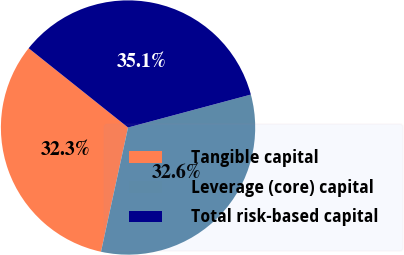Convert chart. <chart><loc_0><loc_0><loc_500><loc_500><pie_chart><fcel>Tangible capital<fcel>Leverage (core) capital<fcel>Total risk-based capital<nl><fcel>32.3%<fcel>32.58%<fcel>35.11%<nl></chart> 